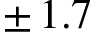<formula> <loc_0><loc_0><loc_500><loc_500>\pm \, 1 . 7</formula> 